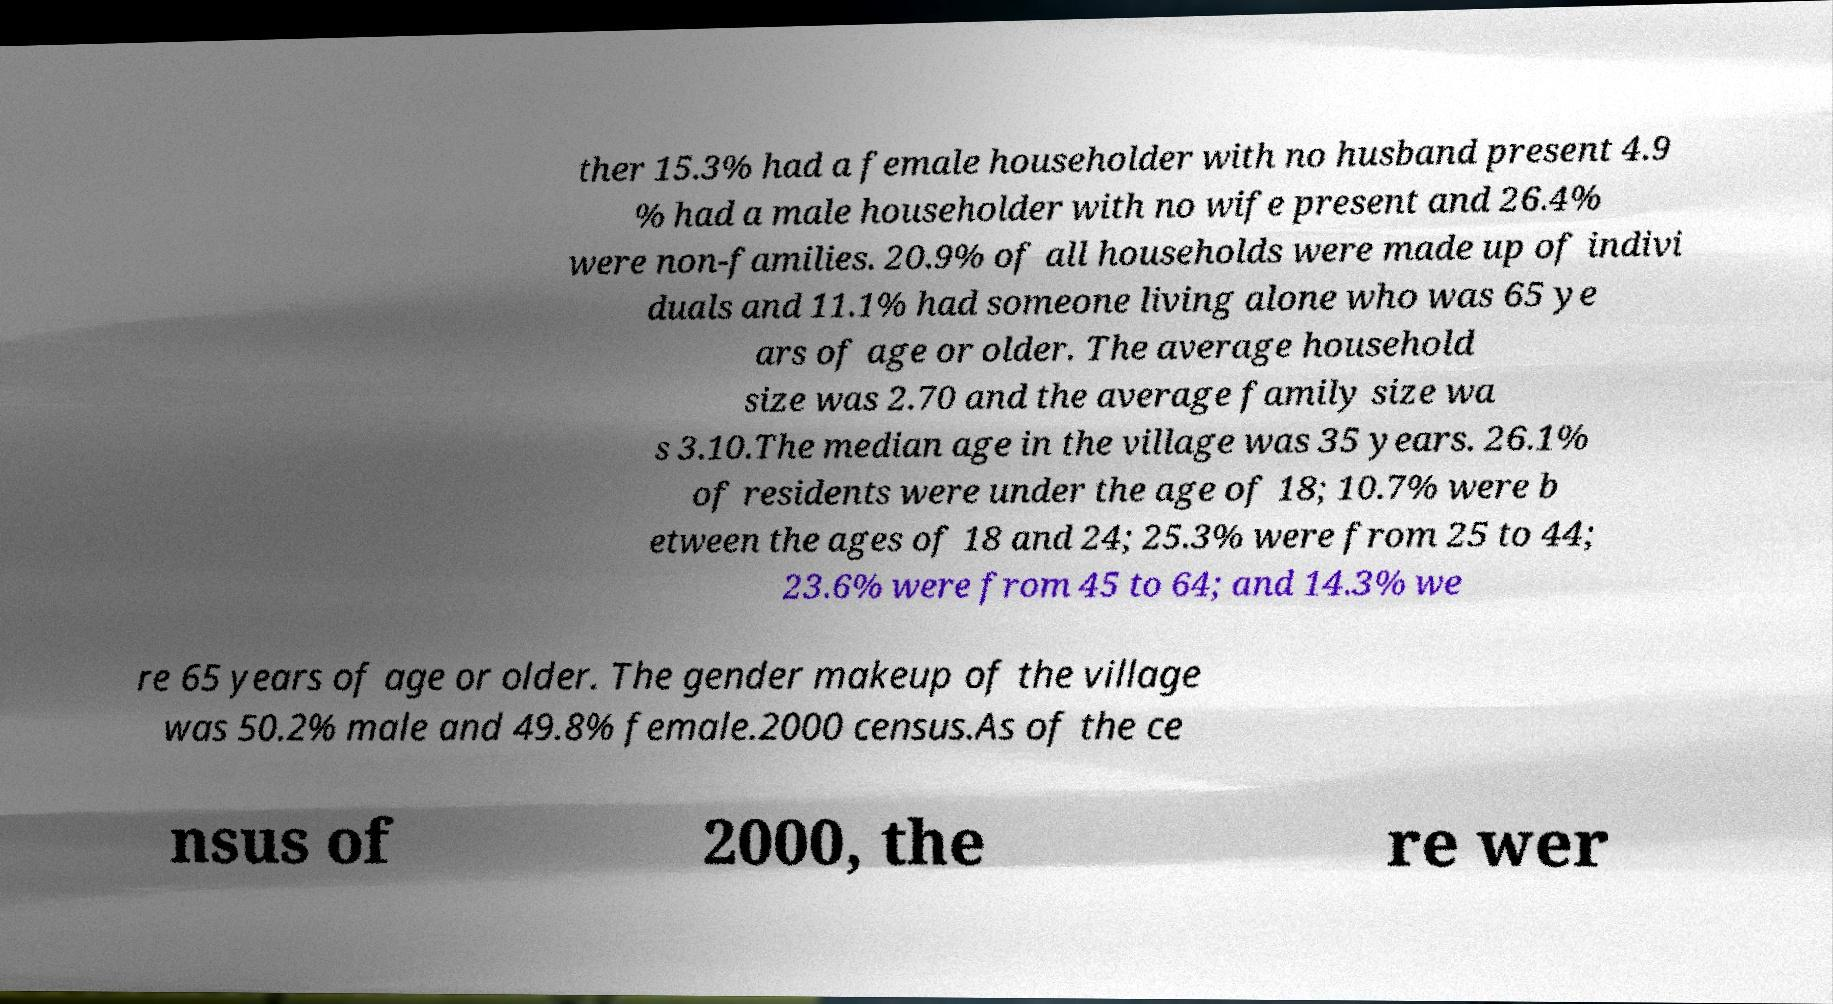Please read and relay the text visible in this image. What does it say? ther 15.3% had a female householder with no husband present 4.9 % had a male householder with no wife present and 26.4% were non-families. 20.9% of all households were made up of indivi duals and 11.1% had someone living alone who was 65 ye ars of age or older. The average household size was 2.70 and the average family size wa s 3.10.The median age in the village was 35 years. 26.1% of residents were under the age of 18; 10.7% were b etween the ages of 18 and 24; 25.3% were from 25 to 44; 23.6% were from 45 to 64; and 14.3% we re 65 years of age or older. The gender makeup of the village was 50.2% male and 49.8% female.2000 census.As of the ce nsus of 2000, the re wer 